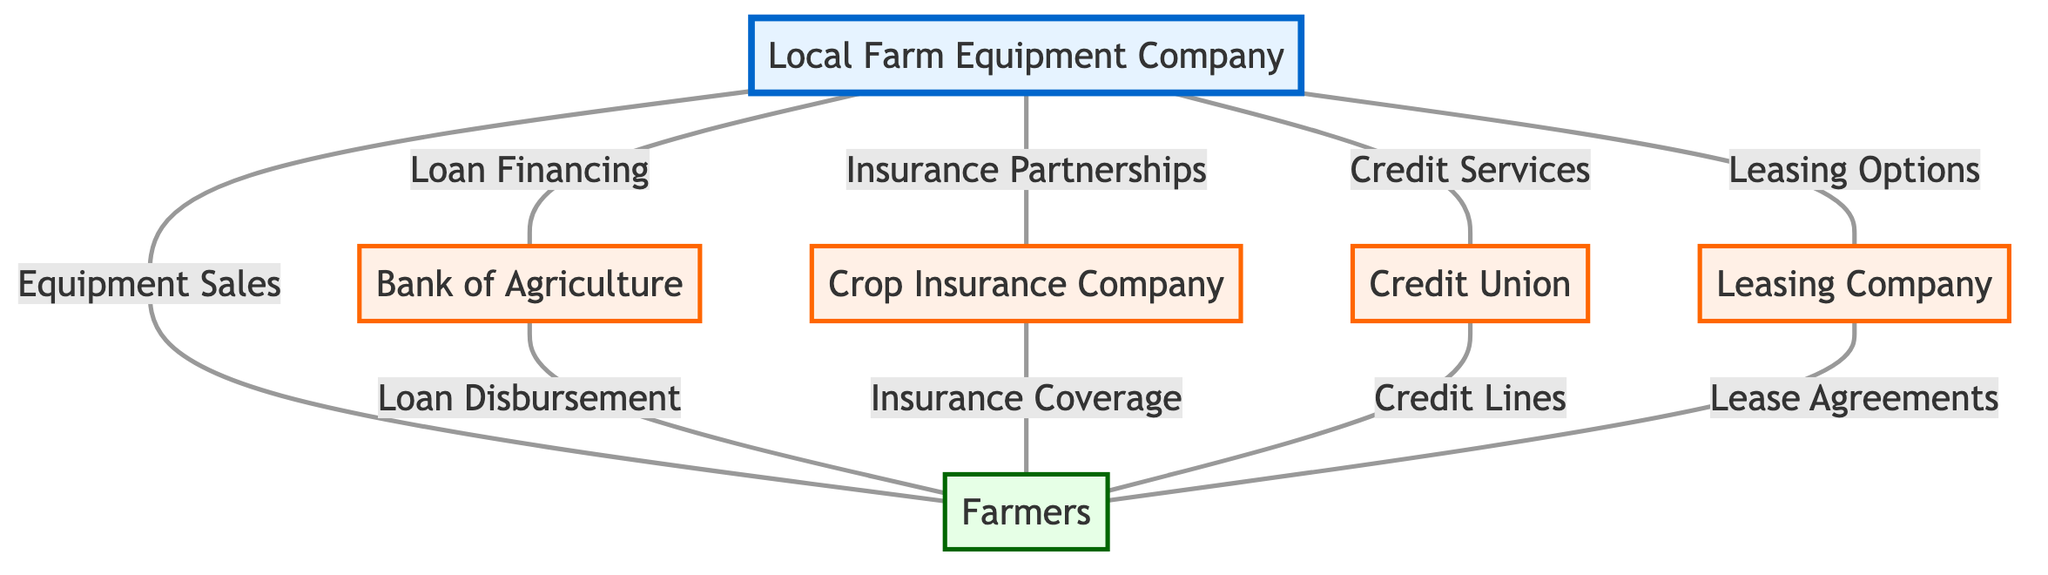What is the total number of nodes in the diagram? The diagram consists of six distinct nodes: the Local Farm Equipment Company, Bank of Agriculture, Crop Insurance Company, Credit Union, Farmers, and Leasing Company. Counting these gives us a total of six nodes.
Answer: 6 What type of relationship exists between the Local Farm Equipment Company and the Bank of Agriculture? The edge connecting these two nodes is labeled "Loan Financing," indicating that the relationship is one of financing loans.
Answer: Loan Financing How many different institutions are connected to the Farmers in the diagram? The diagram shows four distinct institutions connected to the Farmers: Bank of Agriculture, Crop Insurance Company, Credit Union, and Leasing Company. Therefore, there are four institutions connected.
Answer: 4 What is the purpose of the edge connecting the Local Farm Equipment Company to the Credit Union? The edge is labeled "Credit Services," which suggests that the purpose of the connection is to provide credit services for financing.
Answer: Credit Services Which node has the most connections in the diagram? By checking the edges, the Local Farm Equipment Company is connected to five other nodes: Bank of Agriculture, Crop Insurance Company, Credit Union, Farmers, and Leasing Company, making it the most connected node.
Answer: Local Farm Equipment Company What type of partnerships does the Local Farm Equipment Company have with the Crop Insurance Company? The relationship is labeled as "Insurance Partnerships," indicating a form of collaboration between these entities related to insurance.
Answer: Insurance Partnerships Which institution offers Lease Agreements to Farmers? The Leasing Company is specifically connected to Farmers through the edge labeled "Lease Agreements."
Answer: Leasing Company What is the edge label that connects the Bank of Agriculture to the Farmers? The edge between these two nodes is labeled "Loan Disbursement," indicating the function of this connection.
Answer: Loan Disbursement 